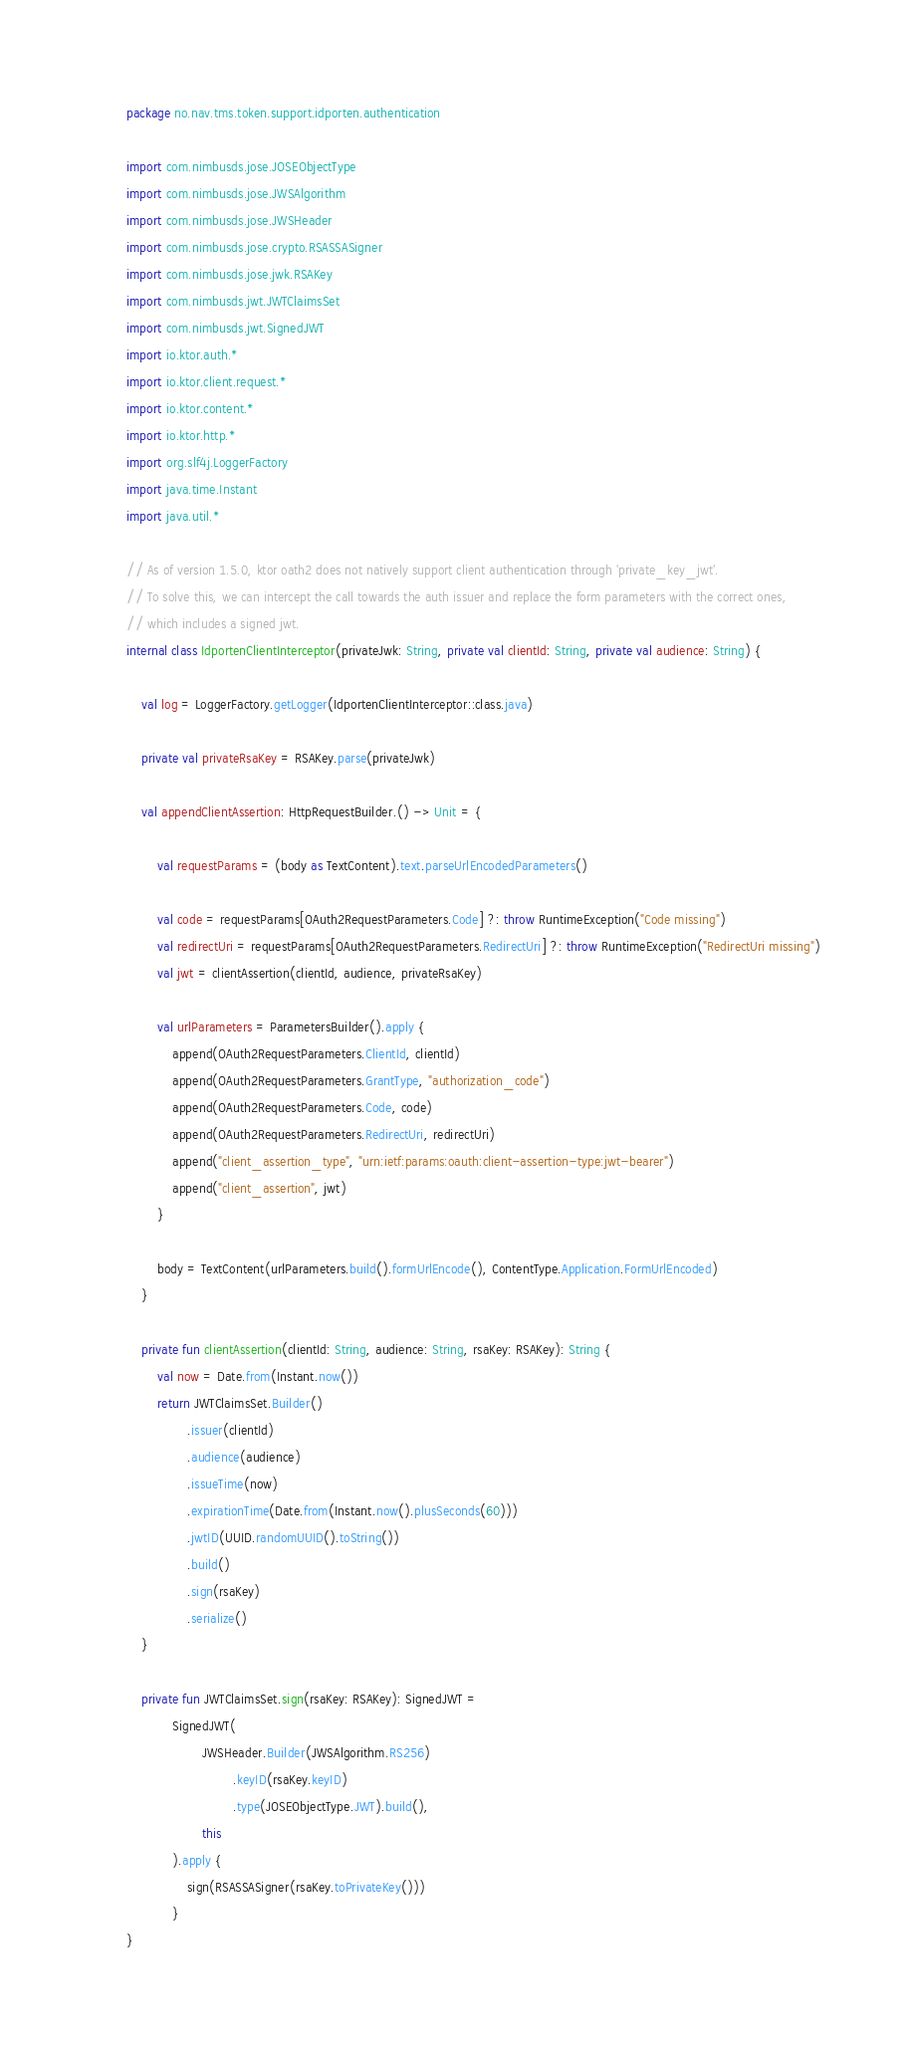<code> <loc_0><loc_0><loc_500><loc_500><_Kotlin_>package no.nav.tms.token.support.idporten.authentication

import com.nimbusds.jose.JOSEObjectType
import com.nimbusds.jose.JWSAlgorithm
import com.nimbusds.jose.JWSHeader
import com.nimbusds.jose.crypto.RSASSASigner
import com.nimbusds.jose.jwk.RSAKey
import com.nimbusds.jwt.JWTClaimsSet
import com.nimbusds.jwt.SignedJWT
import io.ktor.auth.*
import io.ktor.client.request.*
import io.ktor.content.*
import io.ktor.http.*
import org.slf4j.LoggerFactory
import java.time.Instant
import java.util.*

// As of version 1.5.0, ktor oath2 does not natively support client authentication through 'private_key_jwt'.
// To solve this, we can intercept the call towards the auth issuer and replace the form parameters with the correct ones,
// which includes a signed jwt.
internal class IdportenClientInterceptor(privateJwk: String, private val clientId: String, private val audience: String) {

    val log = LoggerFactory.getLogger(IdportenClientInterceptor::class.java)

    private val privateRsaKey = RSAKey.parse(privateJwk)

    val appendClientAssertion: HttpRequestBuilder.() -> Unit = {

        val requestParams = (body as TextContent).text.parseUrlEncodedParameters()

        val code = requestParams[OAuth2RequestParameters.Code] ?: throw RuntimeException("Code missing")
        val redirectUri = requestParams[OAuth2RequestParameters.RedirectUri] ?: throw RuntimeException("RedirectUri missing")
        val jwt = clientAssertion(clientId, audience, privateRsaKey)

        val urlParameters = ParametersBuilder().apply {
            append(OAuth2RequestParameters.ClientId, clientId)
            append(OAuth2RequestParameters.GrantType, "authorization_code")
            append(OAuth2RequestParameters.Code, code)
            append(OAuth2RequestParameters.RedirectUri, redirectUri)
            append("client_assertion_type", "urn:ietf:params:oauth:client-assertion-type:jwt-bearer")
            append("client_assertion", jwt)
        }

        body = TextContent(urlParameters.build().formUrlEncode(), ContentType.Application.FormUrlEncoded)
    }

    private fun clientAssertion(clientId: String, audience: String, rsaKey: RSAKey): String {
        val now = Date.from(Instant.now())
        return JWTClaimsSet.Builder()
                .issuer(clientId)
                .audience(audience)
                .issueTime(now)
                .expirationTime(Date.from(Instant.now().plusSeconds(60)))
                .jwtID(UUID.randomUUID().toString())
                .build()
                .sign(rsaKey)
                .serialize()
    }

    private fun JWTClaimsSet.sign(rsaKey: RSAKey): SignedJWT =
            SignedJWT(
                    JWSHeader.Builder(JWSAlgorithm.RS256)
                            .keyID(rsaKey.keyID)
                            .type(JOSEObjectType.JWT).build(),
                    this
            ).apply {
                sign(RSASSASigner(rsaKey.toPrivateKey()))
            }
}
</code> 